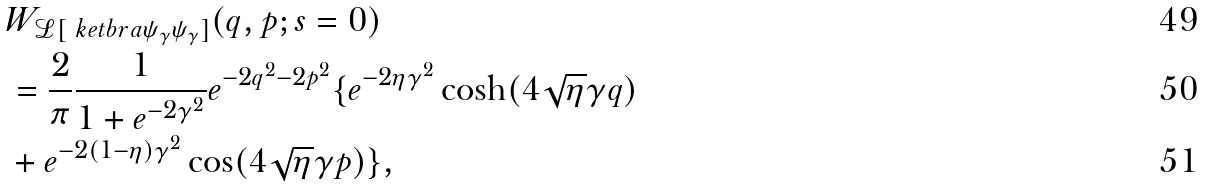Convert formula to latex. <formula><loc_0><loc_0><loc_500><loc_500>& W _ { \mathcal { L } [ \ k e t b r a { \psi _ { \gamma } } { \psi _ { \gamma } } ] } ( q , p ; s = 0 ) \\ & = \frac { 2 } { \pi } \frac { 1 } { 1 + e ^ { - 2 \gamma ^ { 2 } } } e ^ { - 2 q ^ { 2 } - 2 p ^ { 2 } } \{ e ^ { - 2 \eta \gamma ^ { 2 } } \cosh ( 4 \sqrt { \eta } \gamma q ) \\ & + e ^ { - 2 ( 1 - \eta ) \gamma ^ { 2 } } \cos ( 4 \sqrt { \eta } \gamma p ) \} ,</formula> 